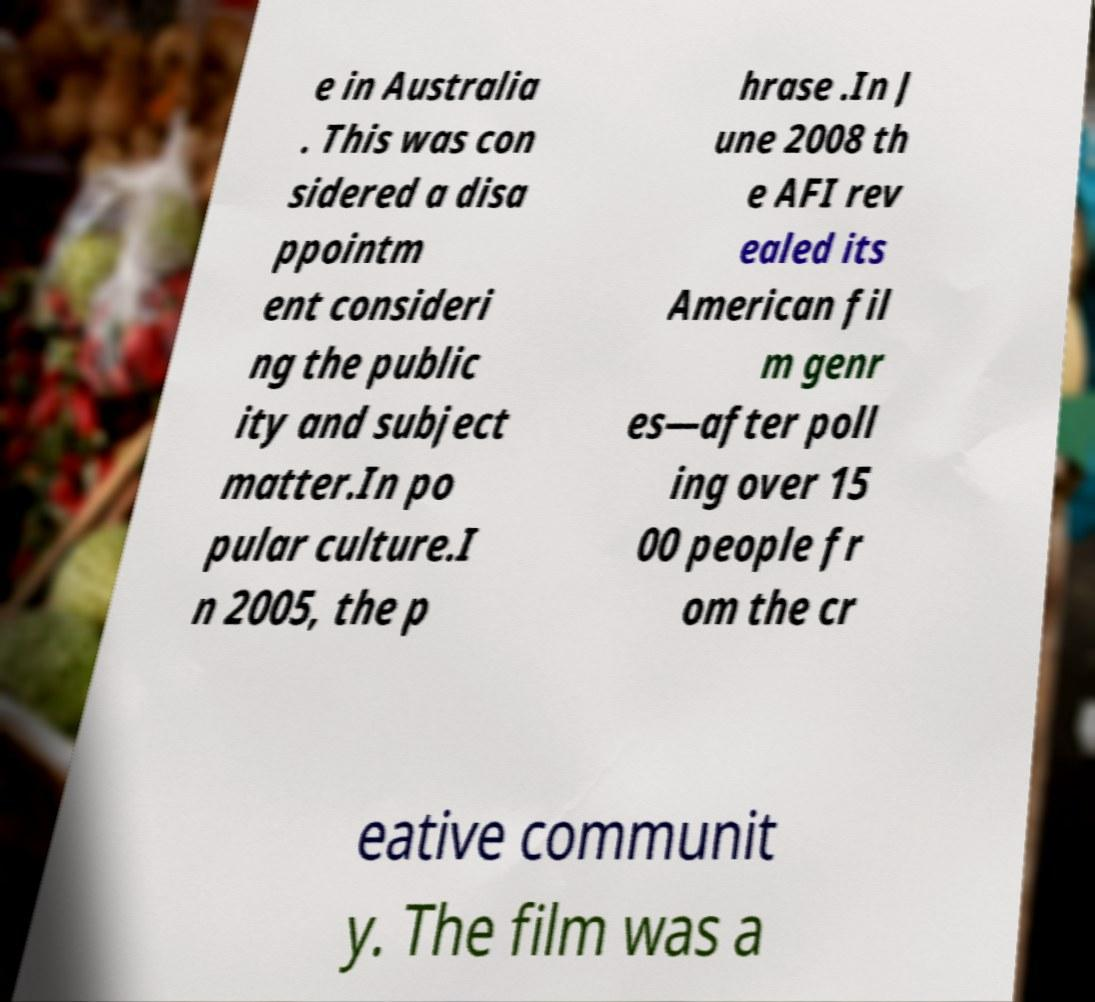Could you extract and type out the text from this image? e in Australia . This was con sidered a disa ppointm ent consideri ng the public ity and subject matter.In po pular culture.I n 2005, the p hrase .In J une 2008 th e AFI rev ealed its American fil m genr es—after poll ing over 15 00 people fr om the cr eative communit y. The film was a 